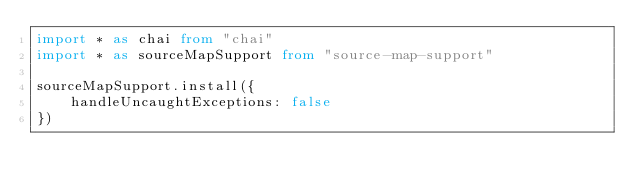Convert code to text. <code><loc_0><loc_0><loc_500><loc_500><_TypeScript_>import * as chai from "chai"
import * as sourceMapSupport from "source-map-support"

sourceMapSupport.install({
    handleUncaughtExceptions: false
})
</code> 